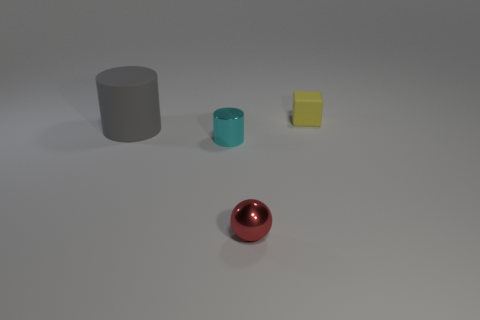Add 4 red rubber objects. How many objects exist? 8 Subtract all spheres. How many objects are left? 3 Subtract 0 yellow cylinders. How many objects are left? 4 Subtract all large gray rubber things. Subtract all gray cylinders. How many objects are left? 2 Add 4 tiny cyan cylinders. How many tiny cyan cylinders are left? 5 Add 3 tiny red things. How many tiny red things exist? 4 